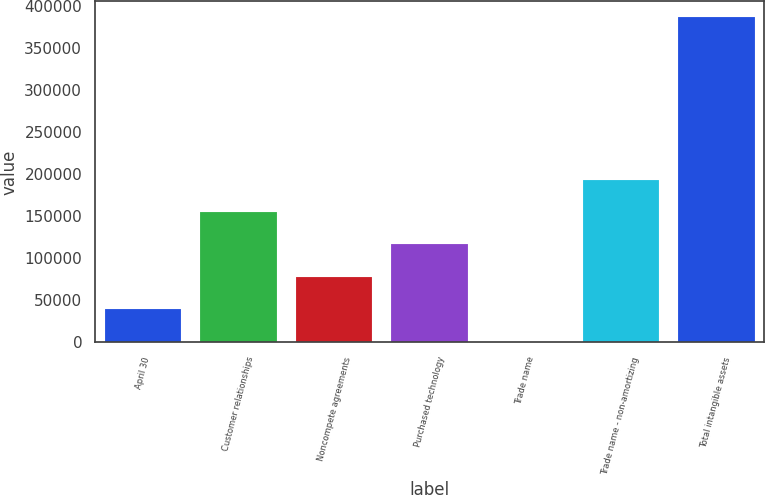Convert chart. <chart><loc_0><loc_0><loc_500><loc_500><bar_chart><fcel>April 30<fcel>Customer relationships<fcel>Noncompete agreements<fcel>Purchased technology<fcel>Trade name<fcel>Trade name - non-amortizing<fcel>Total intangible assets<nl><fcel>39327<fcel>154884<fcel>77846<fcel>116365<fcel>808<fcel>193403<fcel>385998<nl></chart> 